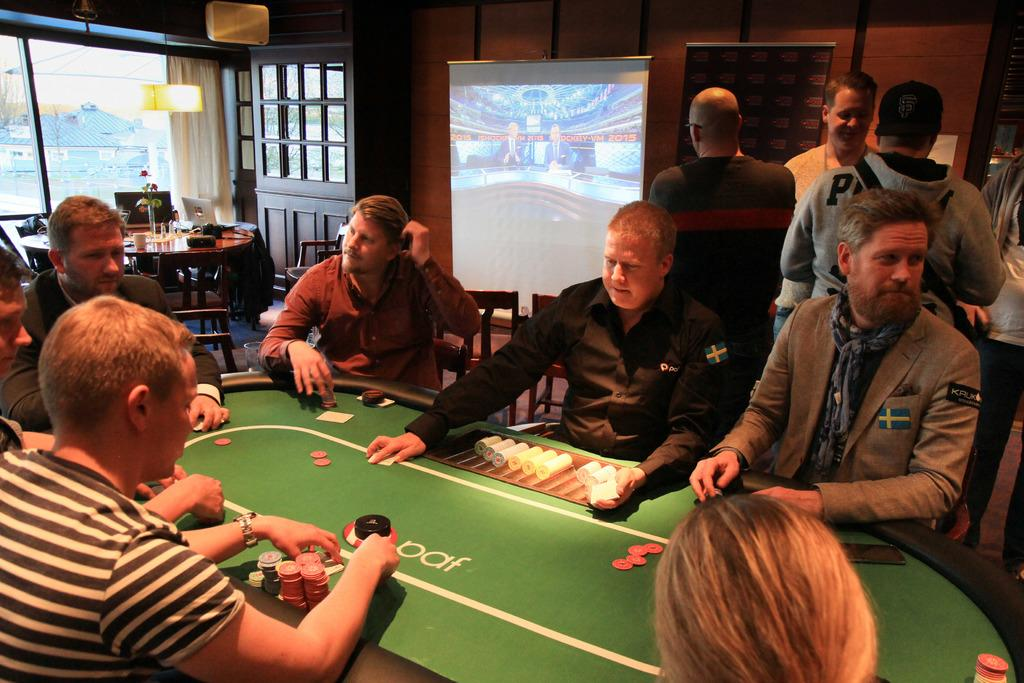What type of structure can be seen in the image? There is a wall in the image. Is there any opening in the wall? Yes, there is a window in the image. What is present on the wall? There is a screen on the wall. What are the people in the image doing? Some people are standing, and others are sitting on chairs in the image. What type of caption is written on the wall in the image? There is no caption written on the wall in the image. Can you see any rabbits in the image? There are no rabbits present in the image. 